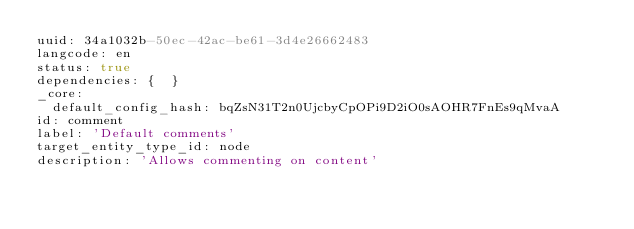Convert code to text. <code><loc_0><loc_0><loc_500><loc_500><_YAML_>uuid: 34a1032b-50ec-42ac-be61-3d4e26662483
langcode: en
status: true
dependencies: {  }
_core:
  default_config_hash: bqZsN31T2n0UjcbyCpOPi9D2iO0sAOHR7FnEs9qMvaA
id: comment
label: 'Default comments'
target_entity_type_id: node
description: 'Allows commenting on content'
</code> 